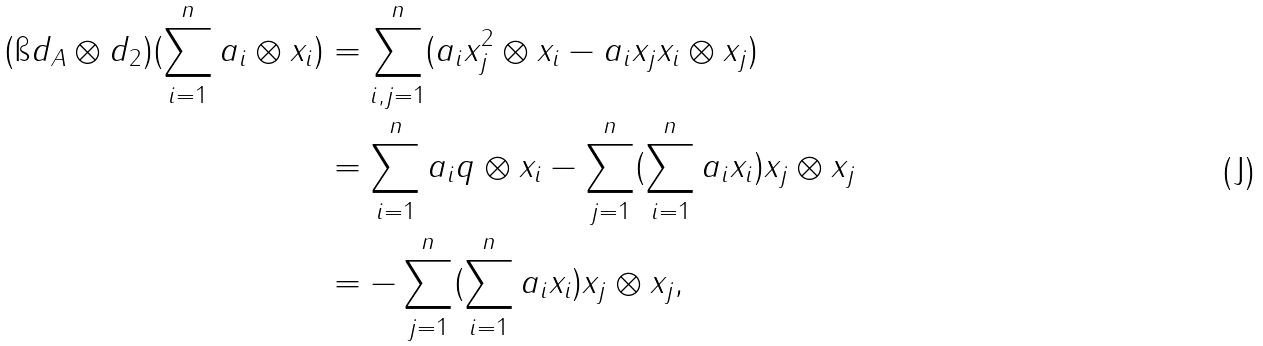<formula> <loc_0><loc_0><loc_500><loc_500>( \i d _ { A } \otimes d _ { 2 } ) ( \sum _ { i = 1 } ^ { n } a _ { i } \otimes x _ { i } ) & = \sum _ { i , j = 1 } ^ { n } ( a _ { i } x _ { j } ^ { 2 } \otimes x _ { i } - a _ { i } x _ { j } x _ { i } \otimes x _ { j } ) \\ & = \sum _ { i = 1 } ^ { n } a _ { i } q \otimes x _ { i } - \sum _ { j = 1 } ^ { n } ( \sum _ { i = 1 } ^ { n } a _ { i } x _ { i } ) x _ { j } \otimes x _ { j } \\ & = - \sum _ { j = 1 } ^ { n } ( \sum _ { i = 1 } ^ { n } a _ { i } x _ { i } ) x _ { j } \otimes x _ { j } ,</formula> 